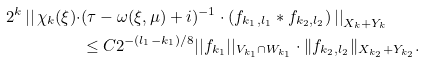Convert formula to latex. <formula><loc_0><loc_0><loc_500><loc_500>2 ^ { k } \left | \right | \chi _ { k } ( \xi ) \cdot & ( \tau - \omega ( \xi , \mu ) + i ) ^ { - 1 } \cdot ( f _ { k _ { 1 } , l _ { 1 } } \ast f _ { k _ { 2 } , l _ { 2 } } ) \left | \right | _ { X _ { k } + Y _ { k } } \\ & \leq C 2 ^ { - ( l _ { 1 } - k _ { 1 } ) / 8 } | | f _ { k _ { 1 } } | | _ { V _ { k _ { 1 } } \cap W _ { k _ { 1 } } } \cdot \| f _ { k _ { 2 } , l _ { 2 } } \| _ { X _ { k _ { 2 } } + Y _ { k _ { 2 } } } .</formula> 